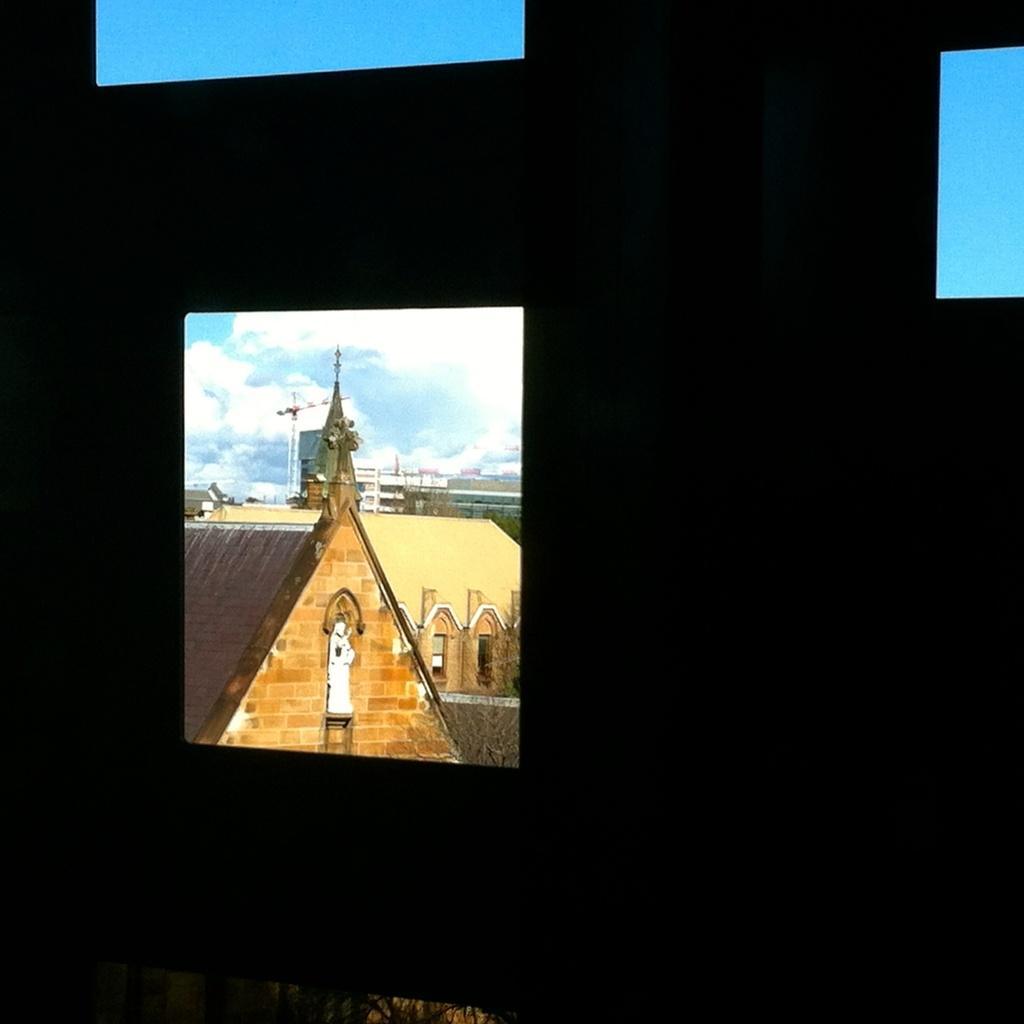Describe this image in one or two sentences. In this image we can see an object which looks like a window, through the window we can see few buildings, a statue to the building, trees and the sky with clouds. 